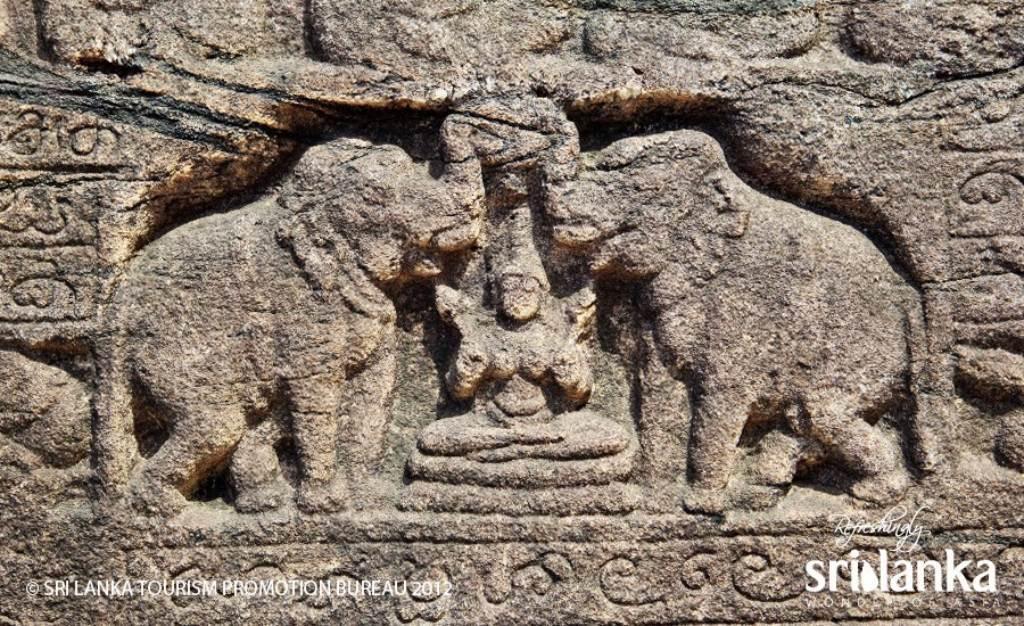Please provide a concise description of this image. In the picture we can see a historical building wall on it, we can see a goddess and besides, we can see two elephants on it which is designed on it. 